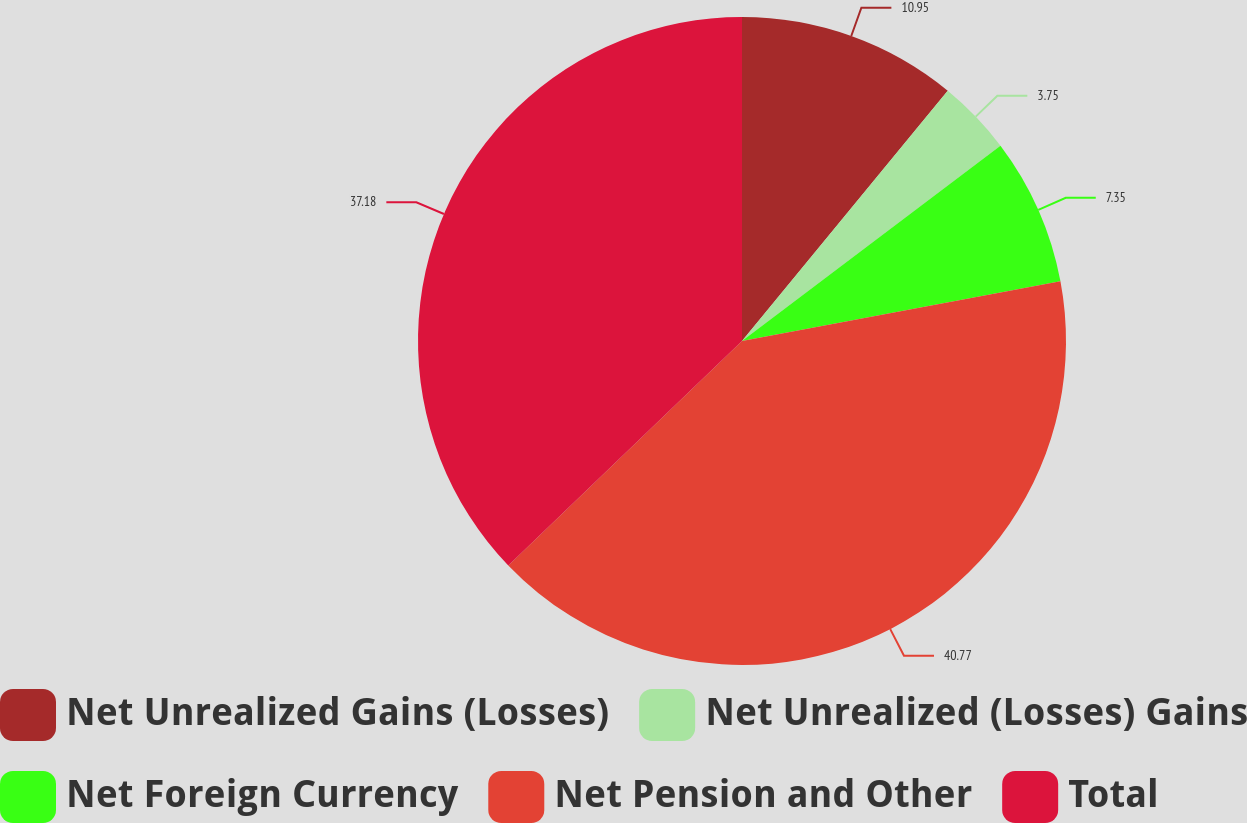Convert chart. <chart><loc_0><loc_0><loc_500><loc_500><pie_chart><fcel>Net Unrealized Gains (Losses)<fcel>Net Unrealized (Losses) Gains<fcel>Net Foreign Currency<fcel>Net Pension and Other<fcel>Total<nl><fcel>10.95%<fcel>3.75%<fcel>7.35%<fcel>40.78%<fcel>37.18%<nl></chart> 